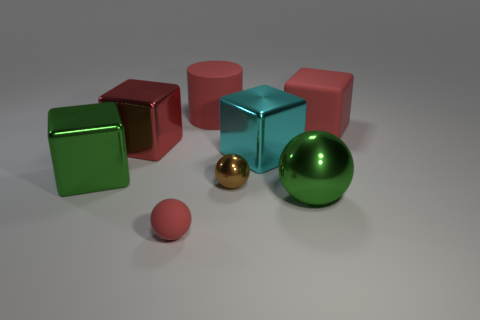Add 1 tiny brown objects. How many objects exist? 9 Subtract all green spheres. How many red blocks are left? 2 Subtract all green metal balls. How many balls are left? 2 Subtract all cylinders. How many objects are left? 7 Subtract all cyan cubes. How many cubes are left? 3 Subtract 1 balls. How many balls are left? 2 Add 4 red shiny blocks. How many red shiny blocks exist? 5 Subtract 2 red blocks. How many objects are left? 6 Subtract all blue spheres. Subtract all blue blocks. How many spheres are left? 3 Subtract all green metallic blocks. Subtract all large red things. How many objects are left? 4 